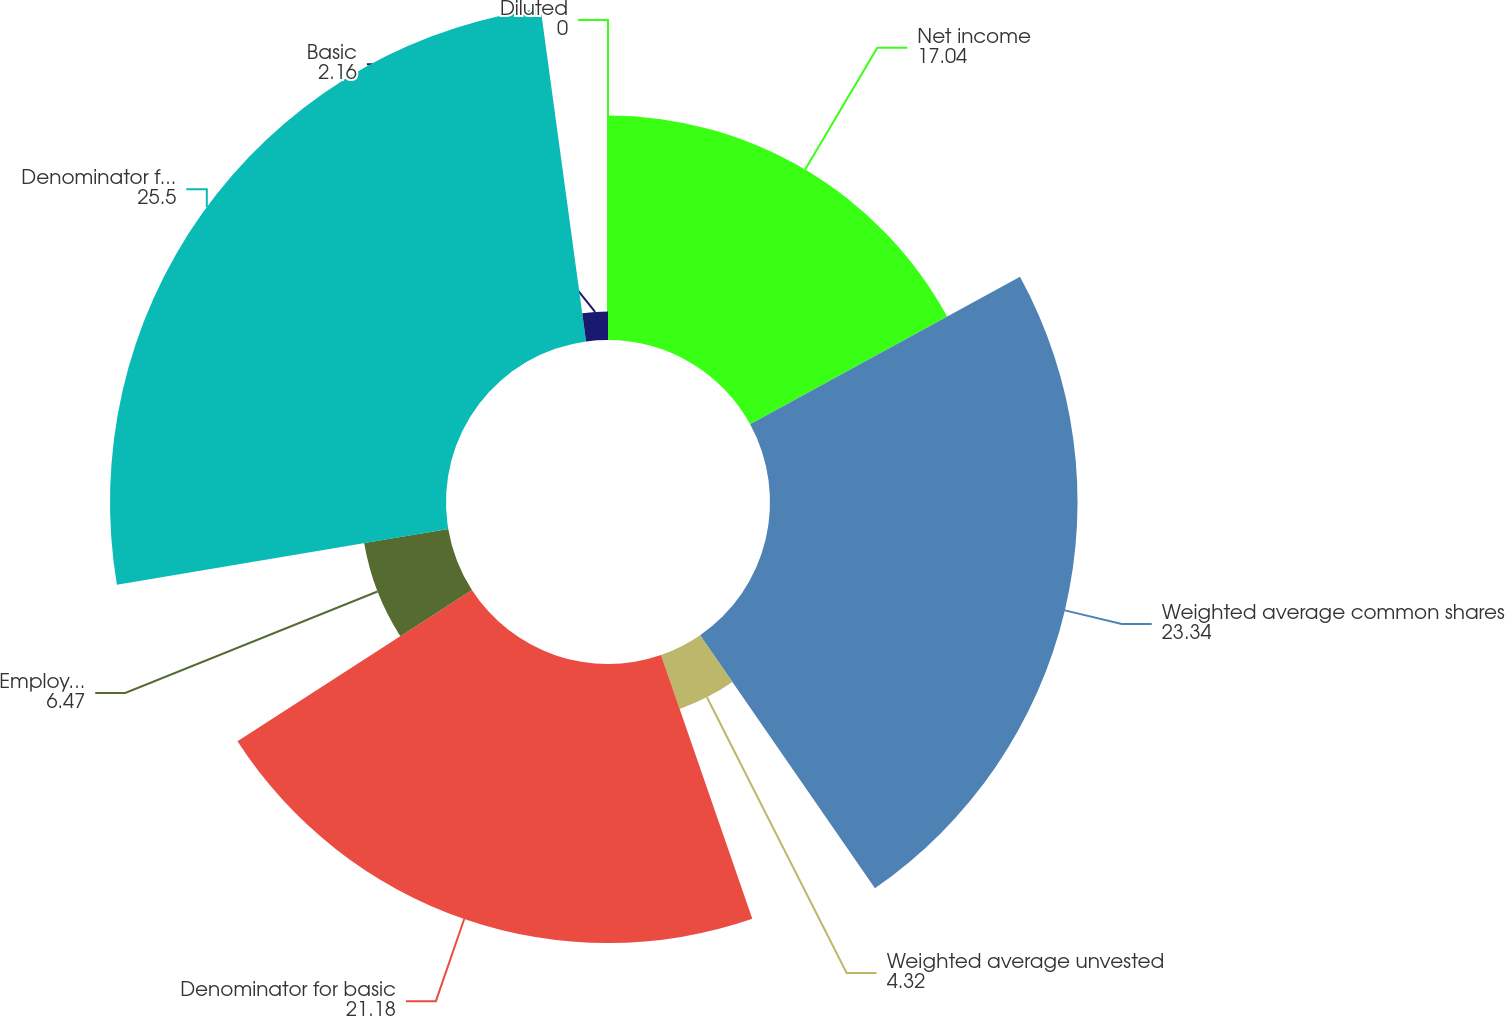Convert chart. <chart><loc_0><loc_0><loc_500><loc_500><pie_chart><fcel>Net income<fcel>Weighted average common shares<fcel>Weighted average unvested<fcel>Denominator for basic<fcel>Employee stock options<fcel>Denominator for diluted<fcel>Basic<fcel>Diluted<nl><fcel>17.04%<fcel>23.34%<fcel>4.32%<fcel>21.18%<fcel>6.47%<fcel>25.5%<fcel>2.16%<fcel>0.0%<nl></chart> 